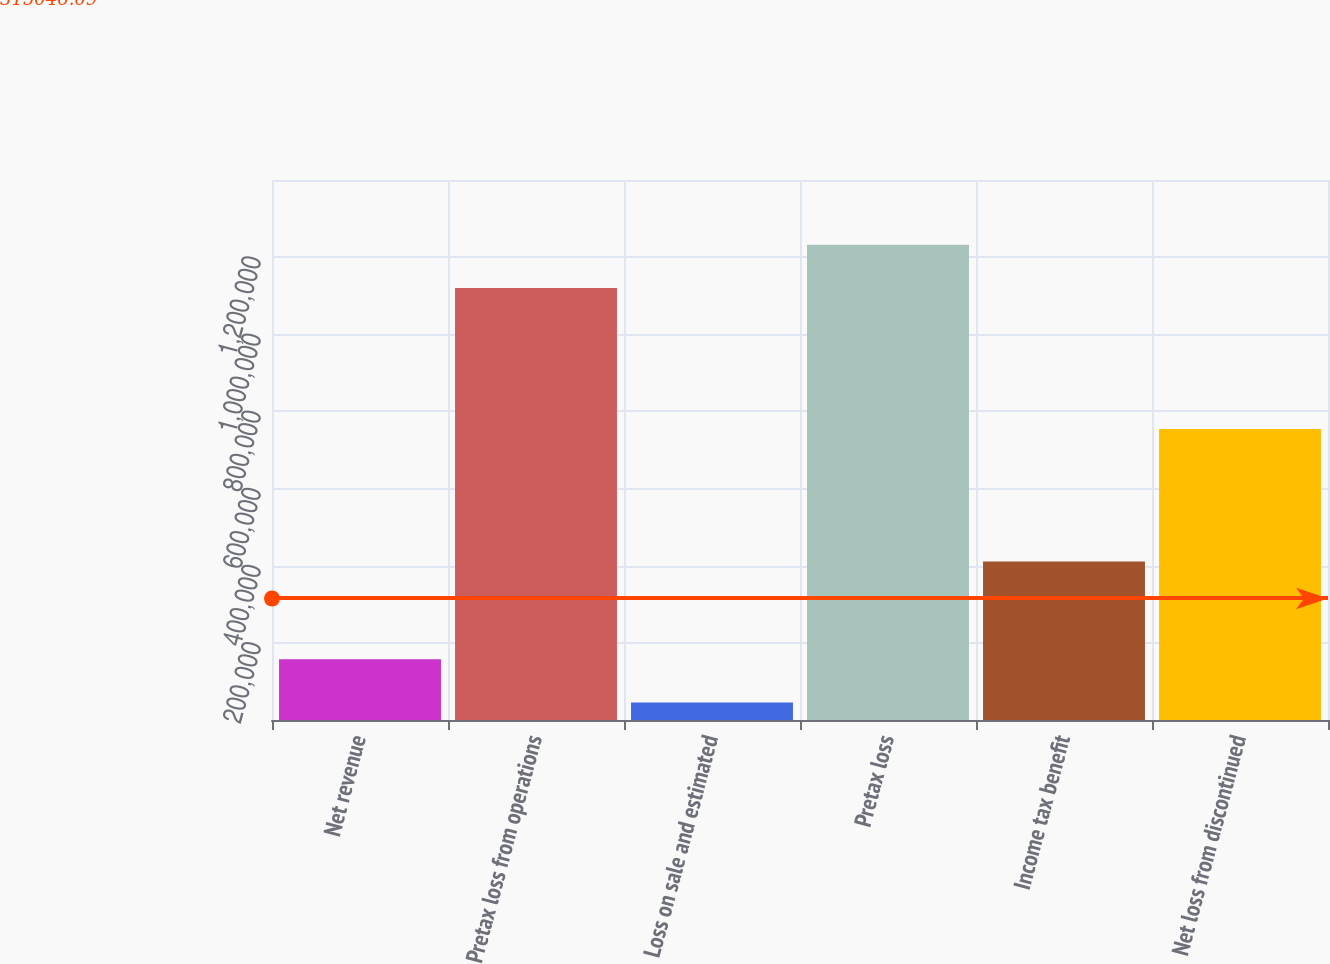Convert chart. <chart><loc_0><loc_0><loc_500><loc_500><bar_chart><fcel>Net revenue<fcel>Pretax loss from operations<fcel>Loss on sale and estimated<fcel>Pretax loss<fcel>Income tax benefit<fcel>Net loss from discontinued<nl><fcel>157532<fcel>1.12022e+06<fcel>45510<fcel>1.23224e+06<fcel>411132<fcel>754594<nl></chart> 